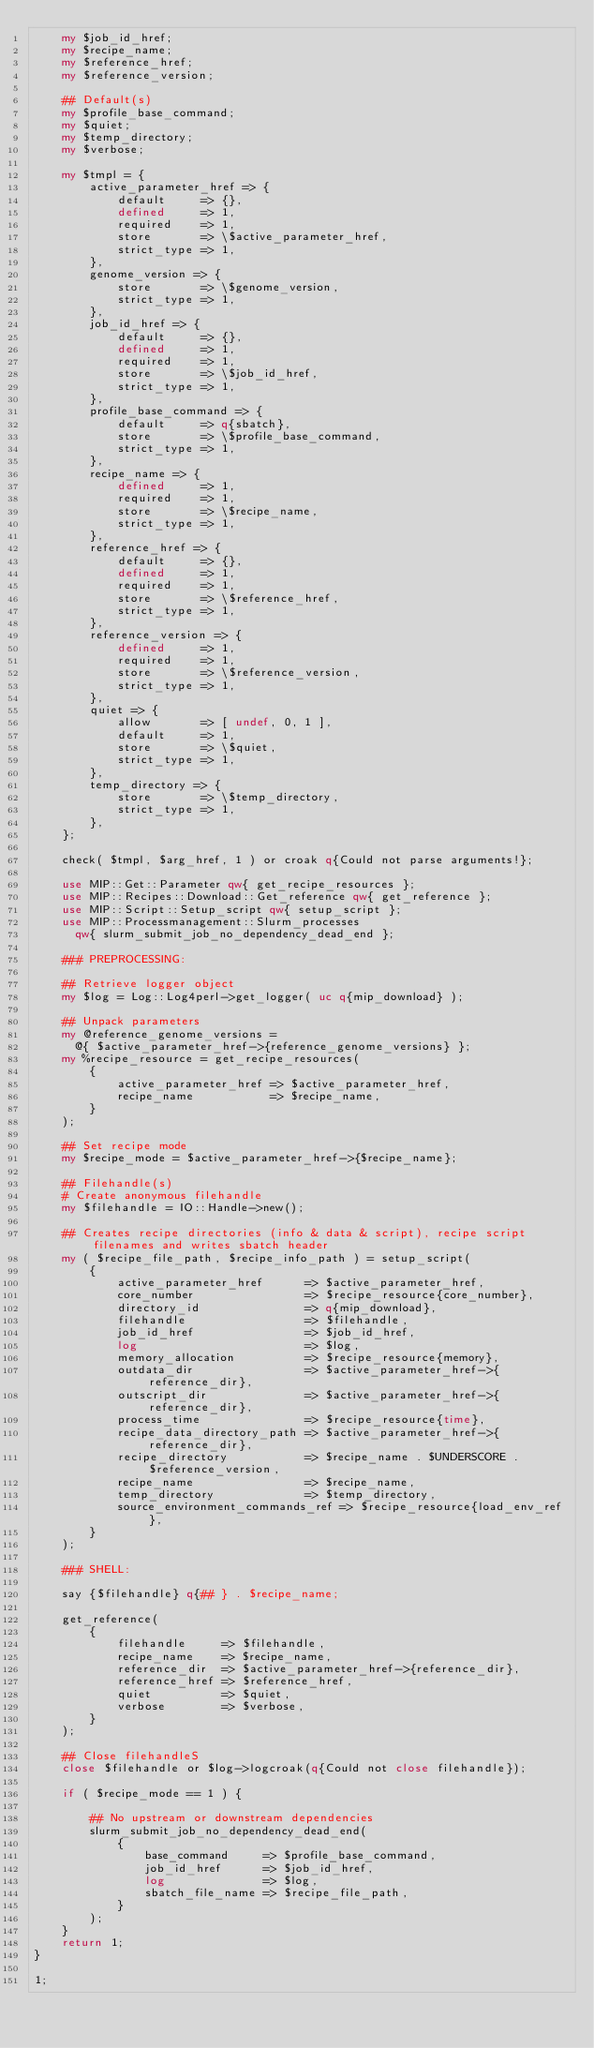Convert code to text. <code><loc_0><loc_0><loc_500><loc_500><_Perl_>    my $job_id_href;
    my $recipe_name;
    my $reference_href;
    my $reference_version;

    ## Default(s)
    my $profile_base_command;
    my $quiet;
    my $temp_directory;
    my $verbose;

    my $tmpl = {
        active_parameter_href => {
            default     => {},
            defined     => 1,
            required    => 1,
            store       => \$active_parameter_href,
            strict_type => 1,
        },
        genome_version => {
            store       => \$genome_version,
            strict_type => 1,
        },
        job_id_href => {
            default     => {},
            defined     => 1,
            required    => 1,
            store       => \$job_id_href,
            strict_type => 1,
        },
        profile_base_command => {
            default     => q{sbatch},
            store       => \$profile_base_command,
            strict_type => 1,
        },
        recipe_name => {
            defined     => 1,
            required    => 1,
            store       => \$recipe_name,
            strict_type => 1,
        },
        reference_href => {
            default     => {},
            defined     => 1,
            required    => 1,
            store       => \$reference_href,
            strict_type => 1,
        },
        reference_version => {
            defined     => 1,
            required    => 1,
            store       => \$reference_version,
            strict_type => 1,
        },
        quiet => {
            allow       => [ undef, 0, 1 ],
            default     => 1,
            store       => \$quiet,
            strict_type => 1,
        },
        temp_directory => {
            store       => \$temp_directory,
            strict_type => 1,
        },
    };

    check( $tmpl, $arg_href, 1 ) or croak q{Could not parse arguments!};

    use MIP::Get::Parameter qw{ get_recipe_resources };
    use MIP::Recipes::Download::Get_reference qw{ get_reference };
    use MIP::Script::Setup_script qw{ setup_script };
    use MIP::Processmanagement::Slurm_processes
      qw{ slurm_submit_job_no_dependency_dead_end };

    ### PREPROCESSING:

    ## Retrieve logger object
    my $log = Log::Log4perl->get_logger( uc q{mip_download} );

    ## Unpack parameters
    my @reference_genome_versions =
      @{ $active_parameter_href->{reference_genome_versions} };
    my %recipe_resource = get_recipe_resources(
        {
            active_parameter_href => $active_parameter_href,
            recipe_name           => $recipe_name,
        }
    );

    ## Set recipe mode
    my $recipe_mode = $active_parameter_href->{$recipe_name};

    ## Filehandle(s)
    # Create anonymous filehandle
    my $filehandle = IO::Handle->new();

    ## Creates recipe directories (info & data & script), recipe script filenames and writes sbatch header
    my ( $recipe_file_path, $recipe_info_path ) = setup_script(
        {
            active_parameter_href      => $active_parameter_href,
            core_number                => $recipe_resource{core_number},
            directory_id               => q{mip_download},
            filehandle                 => $filehandle,
            job_id_href                => $job_id_href,
            log                        => $log,
            memory_allocation          => $recipe_resource{memory},
            outdata_dir                => $active_parameter_href->{reference_dir},
            outscript_dir              => $active_parameter_href->{reference_dir},
            process_time               => $recipe_resource{time},
            recipe_data_directory_path => $active_parameter_href->{reference_dir},
            recipe_directory           => $recipe_name . $UNDERSCORE . $reference_version,
            recipe_name                => $recipe_name,
            temp_directory             => $temp_directory,
            source_environment_commands_ref => $recipe_resource{load_env_ref},
        }
    );

    ### SHELL:

    say {$filehandle} q{## } . $recipe_name;

    get_reference(
        {
            filehandle     => $filehandle,
            recipe_name    => $recipe_name,
            reference_dir  => $active_parameter_href->{reference_dir},
            reference_href => $reference_href,
            quiet          => $quiet,
            verbose        => $verbose,
        }
    );

    ## Close filehandleS
    close $filehandle or $log->logcroak(q{Could not close filehandle});

    if ( $recipe_mode == 1 ) {

        ## No upstream or downstream dependencies
        slurm_submit_job_no_dependency_dead_end(
            {
                base_command     => $profile_base_command,
                job_id_href      => $job_id_href,
                log              => $log,
                sbatch_file_name => $recipe_file_path,
            }
        );
    }
    return 1;
}

1;
</code> 